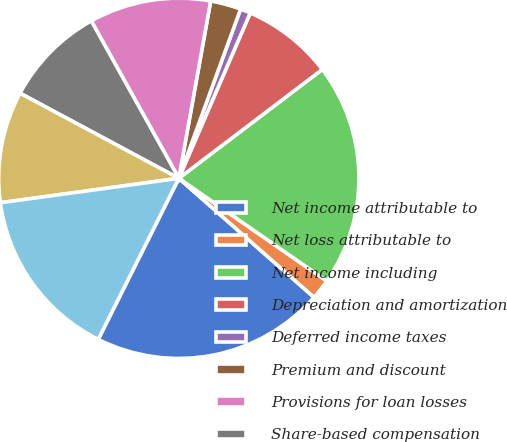Convert chart to OTSL. <chart><loc_0><loc_0><loc_500><loc_500><pie_chart><fcel>Net income attributable to<fcel>Net loss attributable to<fcel>Net income including<fcel>Depreciation and amortization<fcel>Deferred income taxes<fcel>Premium and discount<fcel>Provisions for loan losses<fcel>Share-based compensation<fcel>Other<fcel>Assets segregated pursuant to<nl><fcel>20.9%<fcel>1.83%<fcel>19.99%<fcel>8.18%<fcel>0.92%<fcel>2.74%<fcel>10.91%<fcel>9.09%<fcel>10.0%<fcel>15.45%<nl></chart> 